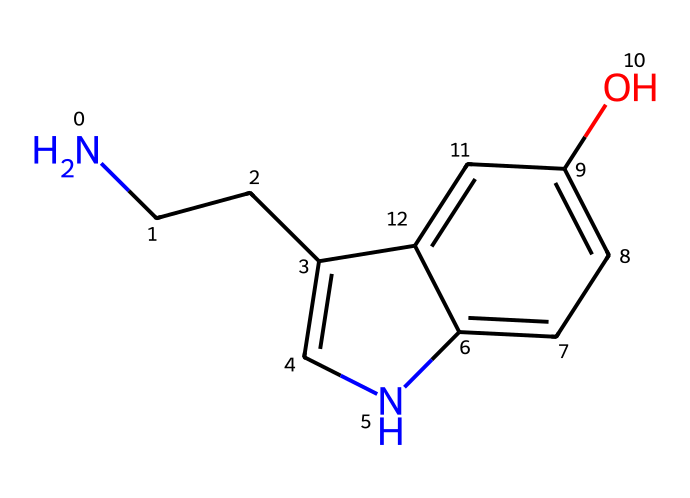What is the molecular formula of this compound? To determine the molecular formula, we need to identify and count the types of atoms present in the SMILES representation. The chemical structure contains C (carbon), H (hydrogen), O (oxygen), and N (nitrogen). Counting these, we find 10 carbon atoms, 12 hydrogen atoms, 1 nitrogen atom, and 1 oxygen atom. Thus, the molecular formula is C10H12N2O.
Answer: C10H12N2O How many rings are present in the structure? Upon analyzing the SMILES representation, we can identify that there are two cyclic components (rings) present in the structure. The notation 'c' indicates carbons that are part of aromatic rings, and the connections suggest the presence of two interconnected rings.
Answer: 2 What functional groups can be identified in this compound? In the given SMILES, the presence of the -NH (amine group) and -OH (hydroxyl group) indicate that this compound has both an amine and an alcohol functional group. The aromatic nature of the structure and the presence of these groups further suggest it behaves as a phenolic compound with relevance to neurotransmitter function.
Answer: amine and hydroxyl What is the relationship between this molecule and mood regulation? This molecule is serotonin, a well-known neurotransmitter that is crucial for mood regulation in the human brain. The presence of the amine and hydroxyl groups plays a significant role in its biological activity and interaction with receptors that influence mood and emotions.
Answer: serotonin Does this molecule contain any chiral centers? To identify chiral centers, we look for carbon atoms that are bonded to four different substituents. In the structure, the carbon connected to the amine and other carbon and hydrogen substituents meets this criterion, indicating that there is indeed one chiral center present.
Answer: 1 